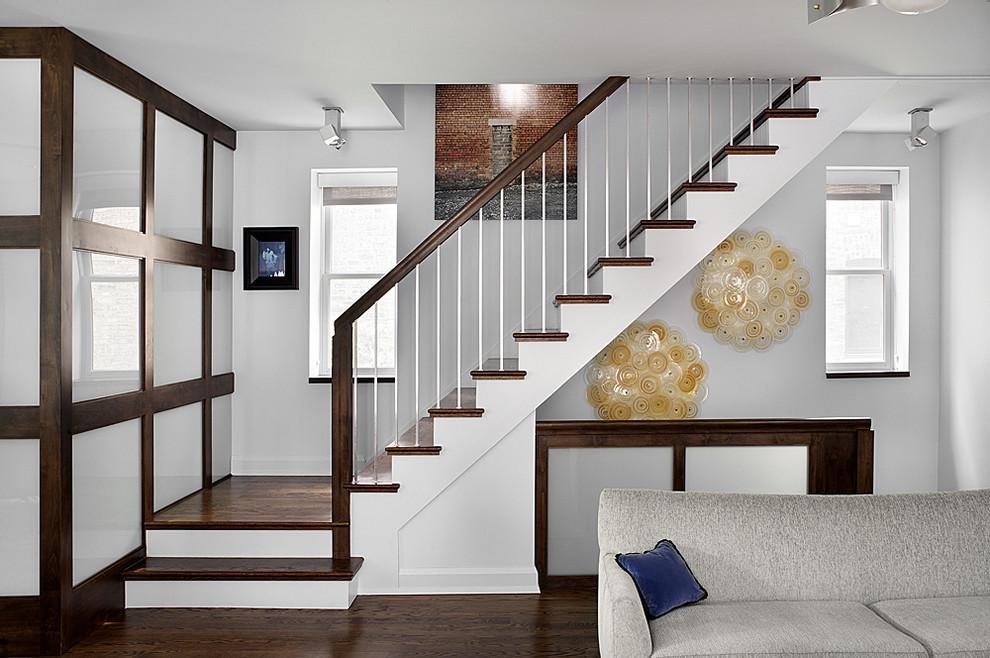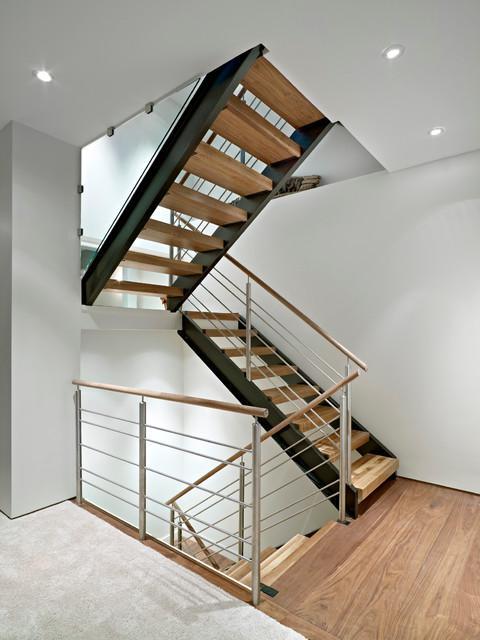The first image is the image on the left, the second image is the image on the right. Considering the images on both sides, is "All the stairs go in at least two directions." valid? Answer yes or no. Yes. The first image is the image on the left, the second image is the image on the right. For the images displayed, is the sentence "One staircase has a white side edge and descends without turns midway, and the other staircase has zig-zag turns." factually correct? Answer yes or no. Yes. 